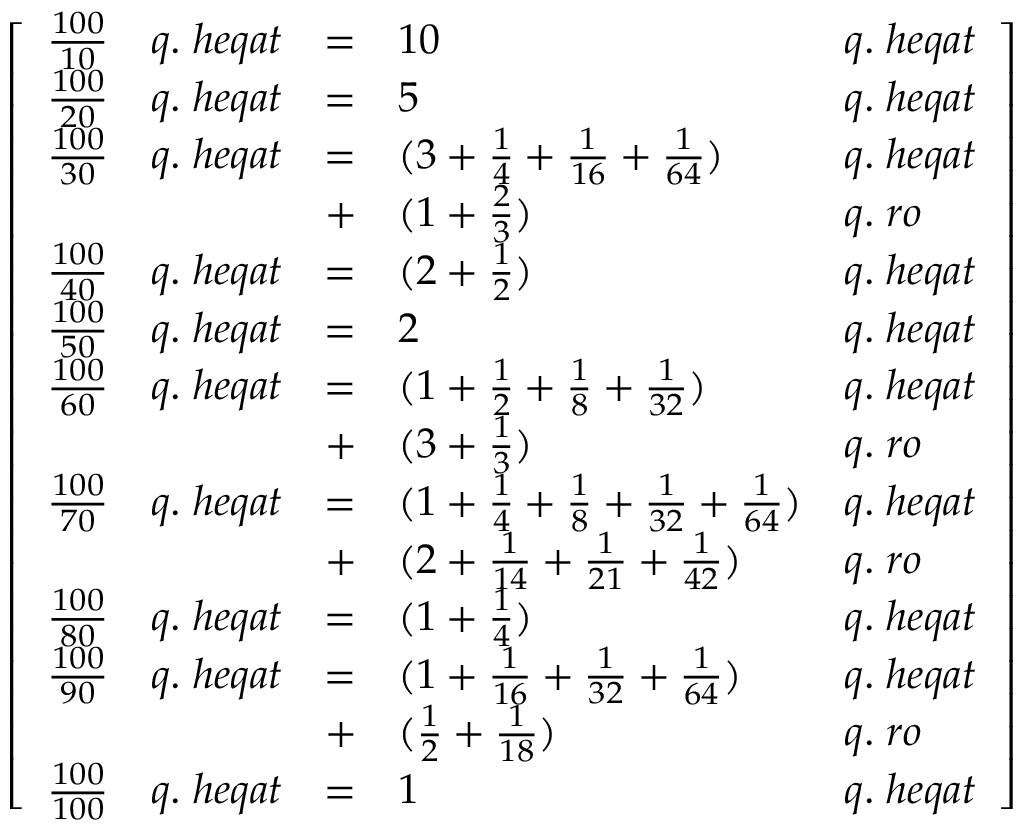<formula> <loc_0><loc_0><loc_500><loc_500>{ \left [ \begin{array} { l l l l l } { { \frac { 1 0 0 } { 1 0 } } } & { q . \, h e q a t } & { = } & { 1 0 } & { q . \, h e q a t } \\ { { \frac { 1 0 0 } { 2 0 } } } & { q . \, h e q a t } & { = } & { 5 } & { q . \, h e q a t } \\ { { \frac { 1 0 0 } { 3 0 } } } & { q . \, h e q a t } & { = } & { ( 3 + { \frac { 1 } { 4 } } + { \frac { 1 } { 1 6 } } + { \frac { 1 } { 6 4 } } ) } & { q . \, h e q a t } \\ & & { + } & { ( 1 + { \frac { 2 } { 3 } } ) } & { q . \, r o } \\ { { \frac { 1 0 0 } { 4 0 } } } & { q . \, h e q a t } & { = } & { ( 2 + { \frac { 1 } { 2 } } ) } & { q . \, h e q a t } \\ { { \frac { 1 0 0 } { 5 0 } } } & { q . \, h e q a t } & { = } & { 2 } & { q . \, h e q a t } \\ { { \frac { 1 0 0 } { 6 0 } } } & { q . \, h e q a t } & { = } & { ( 1 + { \frac { 1 } { 2 } } + { \frac { 1 } { 8 } } + { \frac { 1 } { 3 2 } } ) } & { q . \, h e q a t } \\ & & { + } & { ( 3 + { \frac { 1 } { 3 } } ) } & { q . \, r o } \\ { { \frac { 1 0 0 } { 7 0 } } } & { q . \, h e q a t } & { = } & { ( 1 + { \frac { 1 } { 4 } } + { \frac { 1 } { 8 } } + { \frac { 1 } { 3 2 } } + { \frac { 1 } { 6 4 } } ) } & { q . \, h e q a t } \\ & & { + } & { ( 2 + { \frac { 1 } { 1 4 } } + { \frac { 1 } { 2 1 } } + { \frac { 1 } { 4 2 } } ) } & { q . \, r o } \\ { { \frac { 1 0 0 } { 8 0 } } } & { q . \, h e q a t } & { = } & { ( 1 + { \frac { 1 } { 4 } } ) } & { q . \, h e q a t } \\ { { \frac { 1 0 0 } { 9 0 } } } & { q . \, h e q a t } & { = } & { ( 1 + { \frac { 1 } { 1 6 } } + { \frac { 1 } { 3 2 } } + { \frac { 1 } { 6 4 } } ) } & { q . \, h e q a t } \\ & & { + } & { ( { \frac { 1 } { 2 } } + { \frac { 1 } { 1 8 } } ) } & { q . \, r o } \\ { { \frac { 1 0 0 } { 1 0 0 } } } & { q . \, h e q a t } & { = } & { 1 } & { q . \, h e q a t } \end{array} \right ] }</formula> 